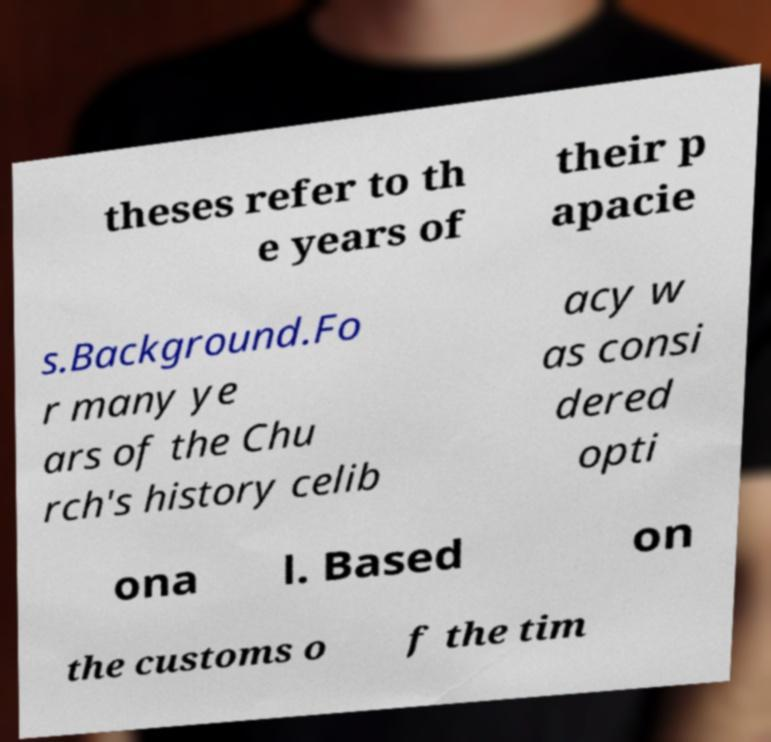Could you assist in decoding the text presented in this image and type it out clearly? theses refer to th e years of their p apacie s.Background.Fo r many ye ars of the Chu rch's history celib acy w as consi dered opti ona l. Based on the customs o f the tim 